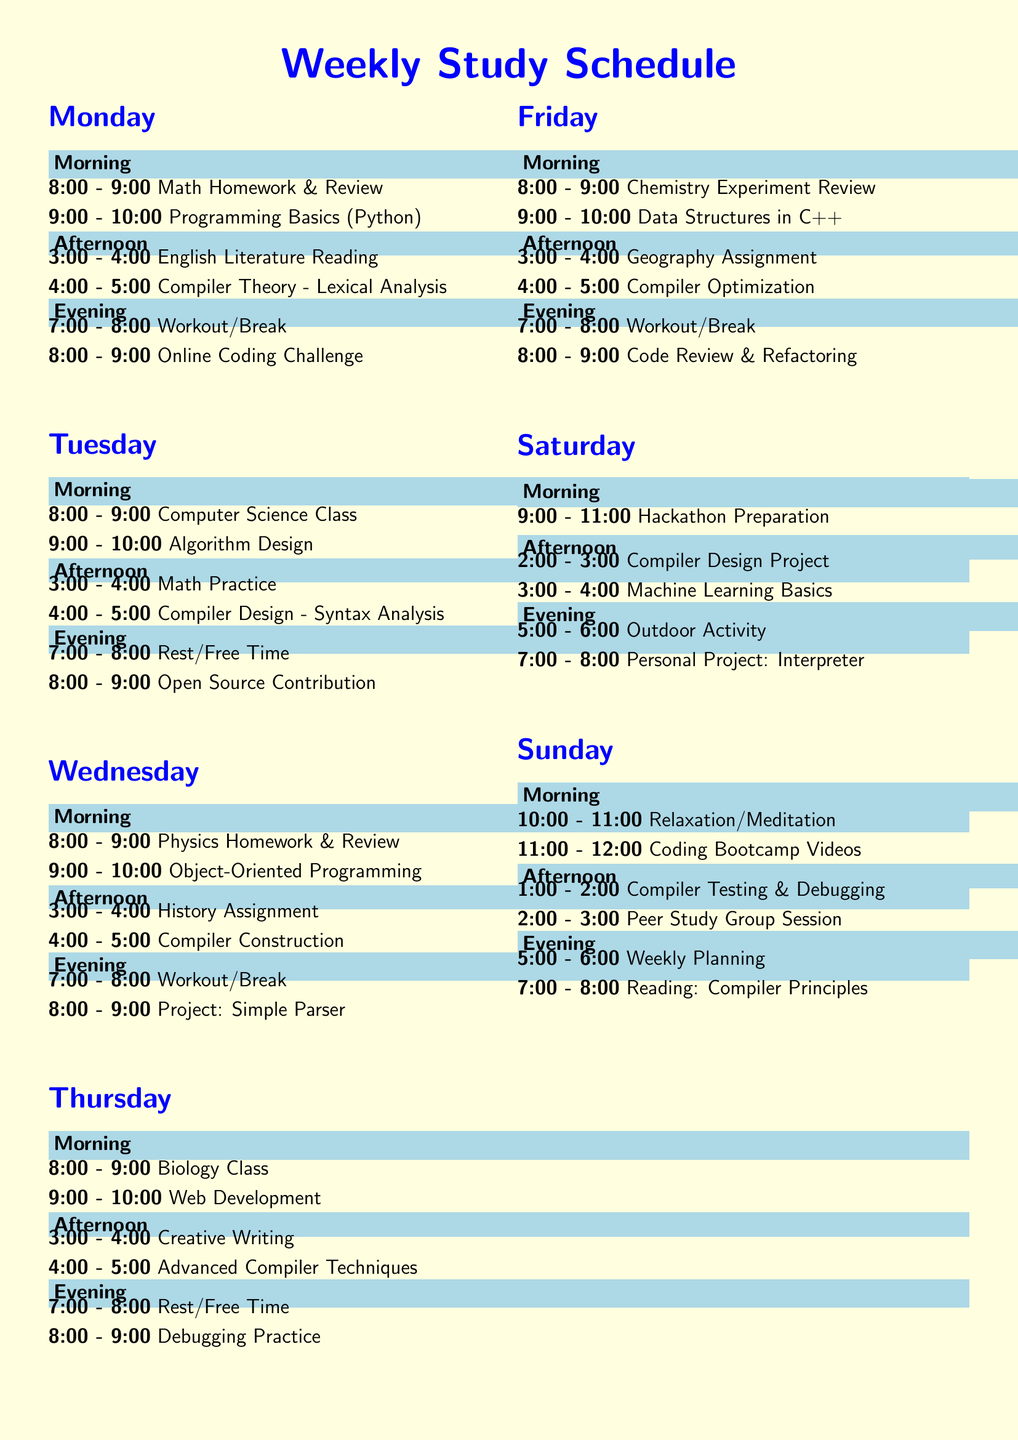What subjects are studied on Monday morning? The subjects studied on Monday morning include Math Homework & Review and Programming Basics (Python).
Answer: Math Homework & Review, Programming Basics (Python) How many hours is dedicated to Compiler Theory on Monday? Compiler Theory is allocated one hour on Monday from 4:00 to 5:00.
Answer: 1 hour What is scheduled for Wednesday evening? Wednesday evening consists of a workout/break followed by a project on a simple parser.
Answer: Workout/Break, Project: Simple Parser Which day includes a session on Compiler Optimization? Compiler Optimization is scheduled for Friday afternoon.
Answer: Friday How many breaks are scheduled throughout the week? Breaks such as workouts/free time are included in the evening sections, implying breaks on Monday, Wednesday, Thursday, and Friday at least.
Answer: 4 What is the focus during the Sunday afternoon study slot? The Sunday afternoon study slot focuses on Compiler Testing & Debugging and Peer Study Group Session.
Answer: Compiler Testing & Debugging, Peer Study Group Session What is the recommended study practice relating to online resources? It is suggested to use online resources like Khan Academy and Coursera for studying.
Answer: Use online resources like Khan Academy and Coursera Which class is studied on Tuesday morning? On Tuesday morning, Computer Science Class is studied.
Answer: Computer Science Class What should you do every hour according to the study tips? It is recommended to take regular breaks every hour to keep your mind fresh.
Answer: Take regular breaks every hour 